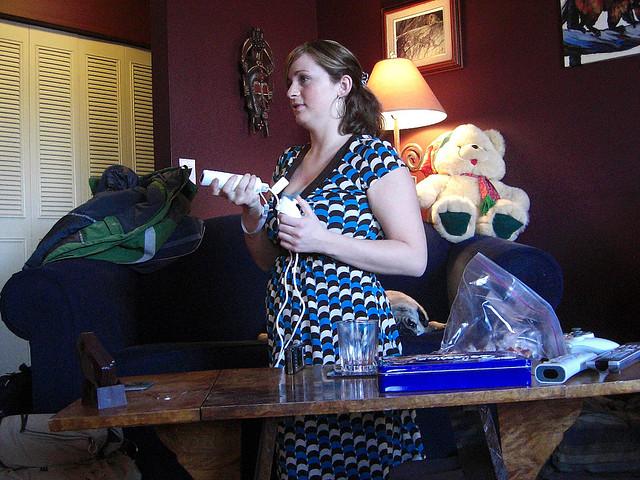What is sitting next to the lamp?
Write a very short answer. Teddy bear. Is this person sitting?
Keep it brief. No. What is the woman holding?
Keep it brief. Controller. 